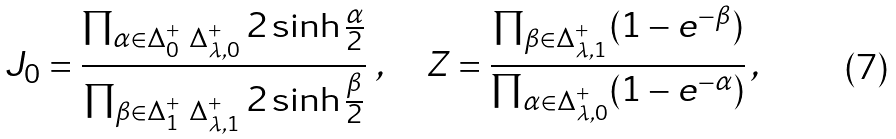<formula> <loc_0><loc_0><loc_500><loc_500>J _ { 0 } = \frac { \prod _ { \alpha \in \Delta _ { 0 } ^ { + } \ \Delta _ { \lambda , 0 } ^ { + } } 2 \sinh \frac { \alpha } { 2 } } { \prod _ { \beta \in \Delta _ { 1 } ^ { + } \ \Delta _ { \lambda , 1 } ^ { + } } 2 \sinh \frac { \beta } { 2 } } \ , \quad Z = \frac { \prod _ { \beta \in \Delta _ { \lambda , 1 } ^ { + } } ( 1 - e ^ { - \beta } ) } { \prod _ { \alpha \in \Delta _ { \lambda , 0 } ^ { + } } ( 1 - e ^ { - \alpha } ) } \, ,</formula> 